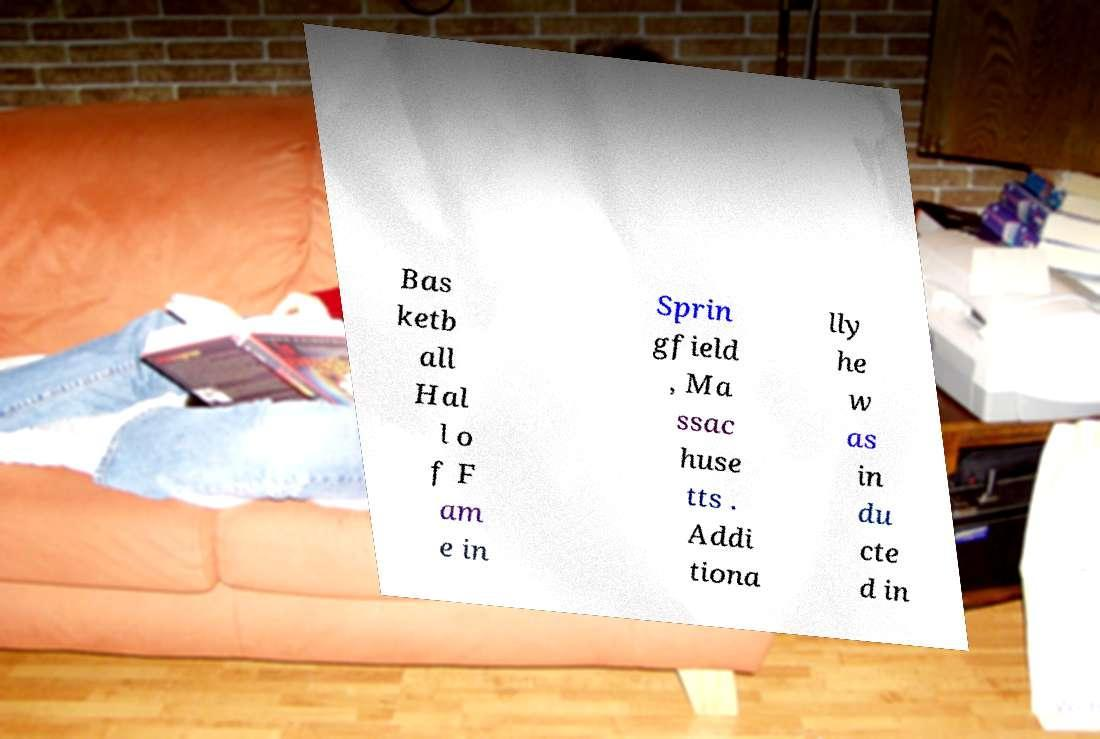Please read and relay the text visible in this image. What does it say? Bas ketb all Hal l o f F am e in Sprin gfield , Ma ssac huse tts . Addi tiona lly he w as in du cte d in 